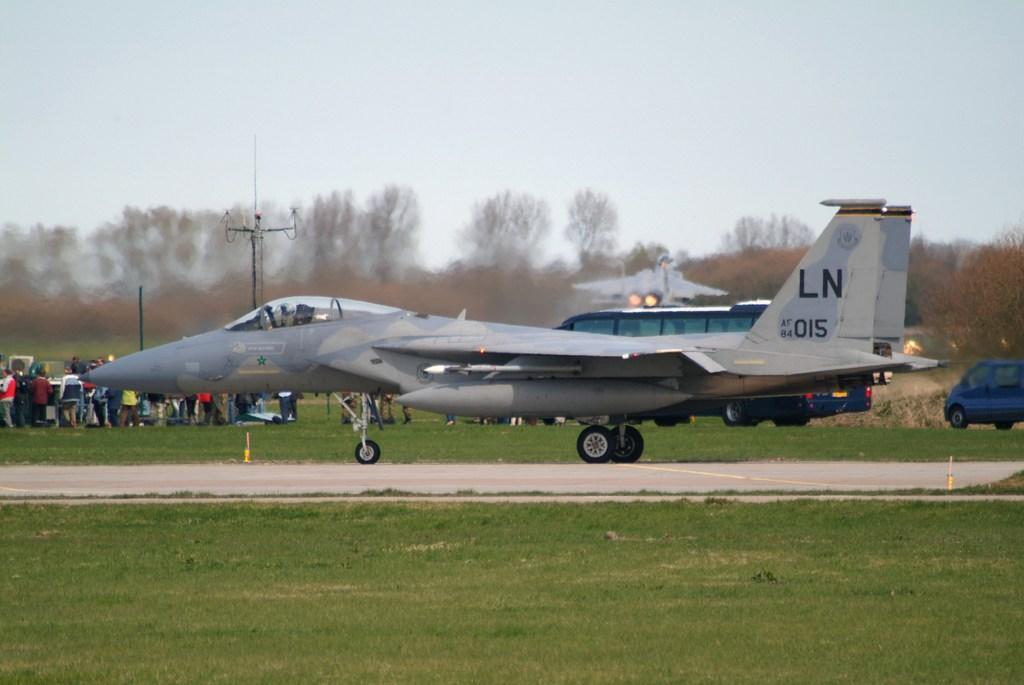<image>
Create a compact narrative representing the image presented. Military plane number LN 015 on the tarmac of an airshow with a crowd in the field next to it. 